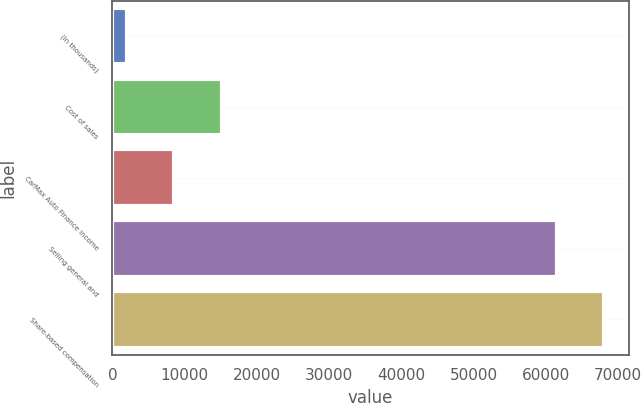Convert chart to OTSL. <chart><loc_0><loc_0><loc_500><loc_500><bar_chart><fcel>(In thousands)<fcel>Cost of sales<fcel>CarMax Auto Finance income<fcel>Selling general and<fcel>Share-based compensation<nl><fcel>2014<fcel>15145.2<fcel>8579.6<fcel>61487<fcel>68052.6<nl></chart> 